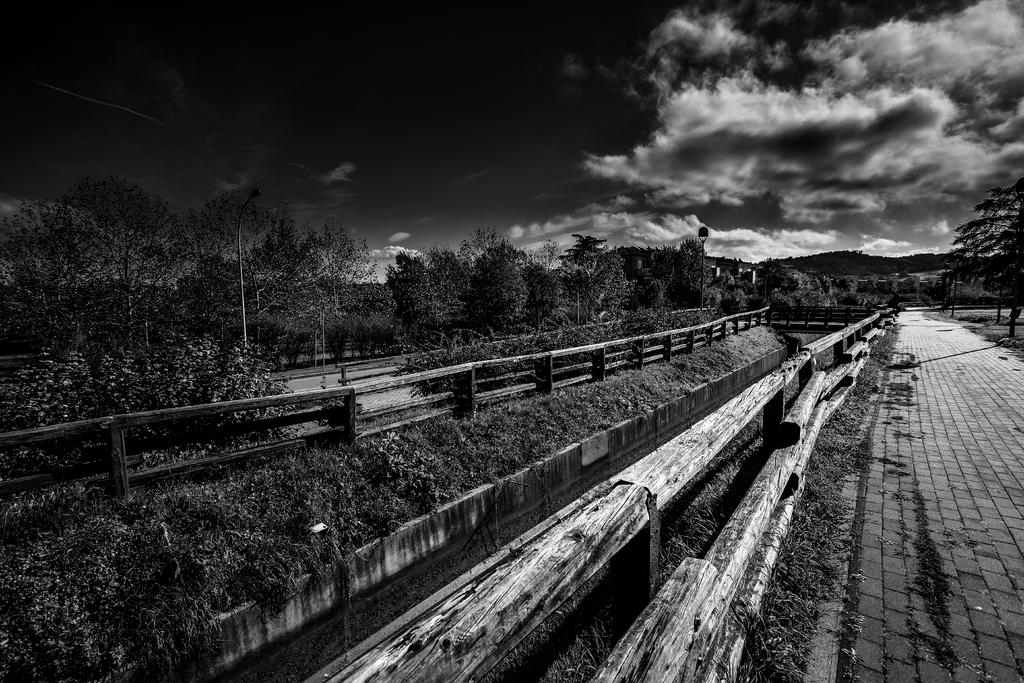What is the color scheme of the image? The image is black and white. What can be seen in the sky in the image? Clouds are present in the sky. What type of structures can be seen in the image? Street poles and street lights are present in the image. What type of vegetation is visible in the image? Trees and grass are visible in the image. What type of barrier is present in the image? Wooden fences are present in the image. What type of surface is visible in the image? Roads are present in the image. How many cacti can be seen growing in the grass in the image? There are no cacti present in the image; the vegetation visible is trees and grass. What type of rock formation can be seen in the background of the image? There are no rock formations visible in the image; the background features sky, clouds, and possibly buildings or other structures. 